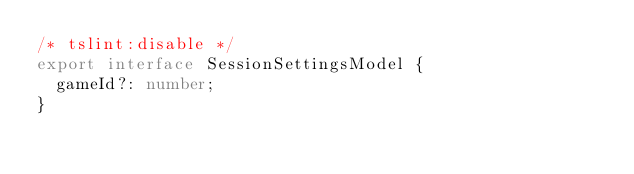Convert code to text. <code><loc_0><loc_0><loc_500><loc_500><_TypeScript_>/* tslint:disable */
export interface SessionSettingsModel {
  gameId?: number;
}
</code> 